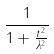<formula> <loc_0><loc_0><loc_500><loc_500>\frac { 1 } { 1 + \frac { t ^ { 2 } } { \lambda ^ { 2 } } }</formula> 